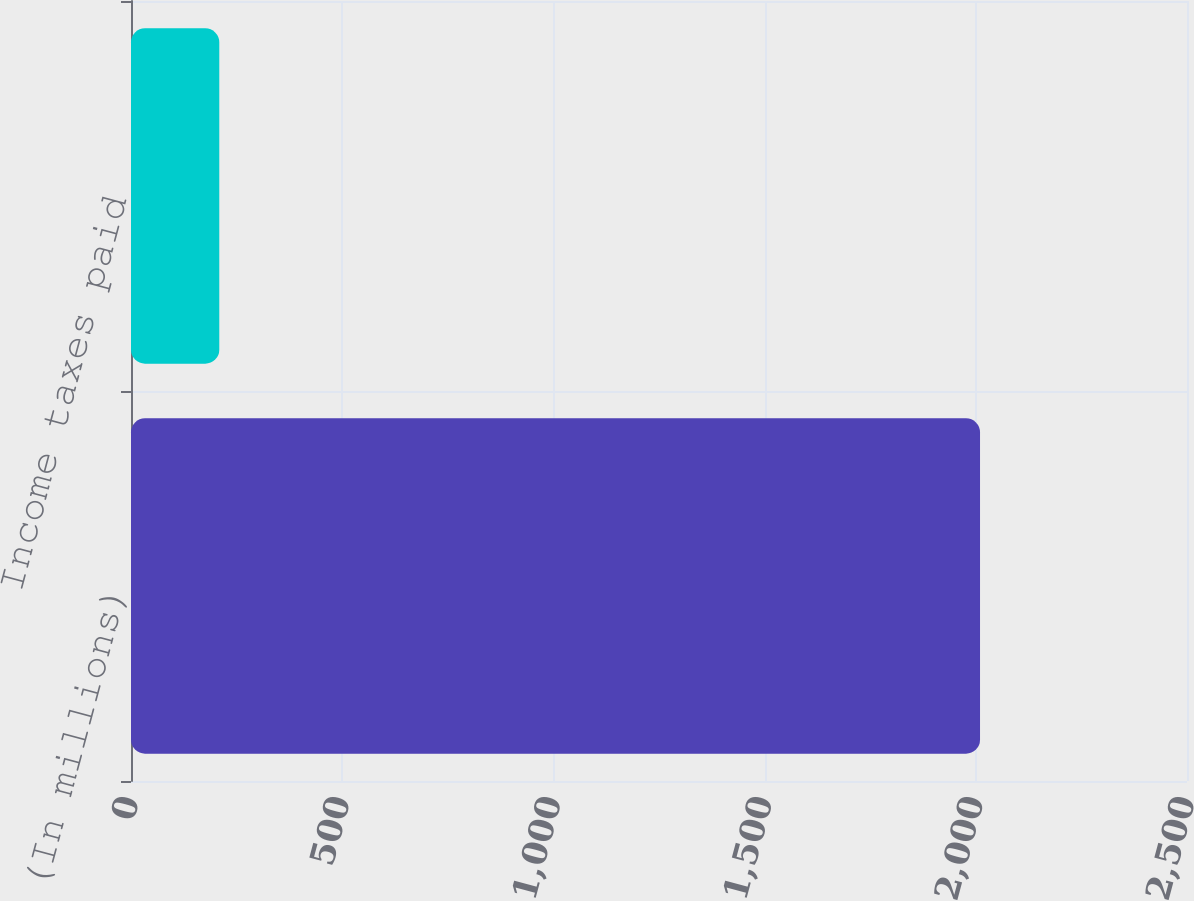<chart> <loc_0><loc_0><loc_500><loc_500><bar_chart><fcel>(In millions)<fcel>Income taxes paid<nl><fcel>2010<fcel>209<nl></chart> 